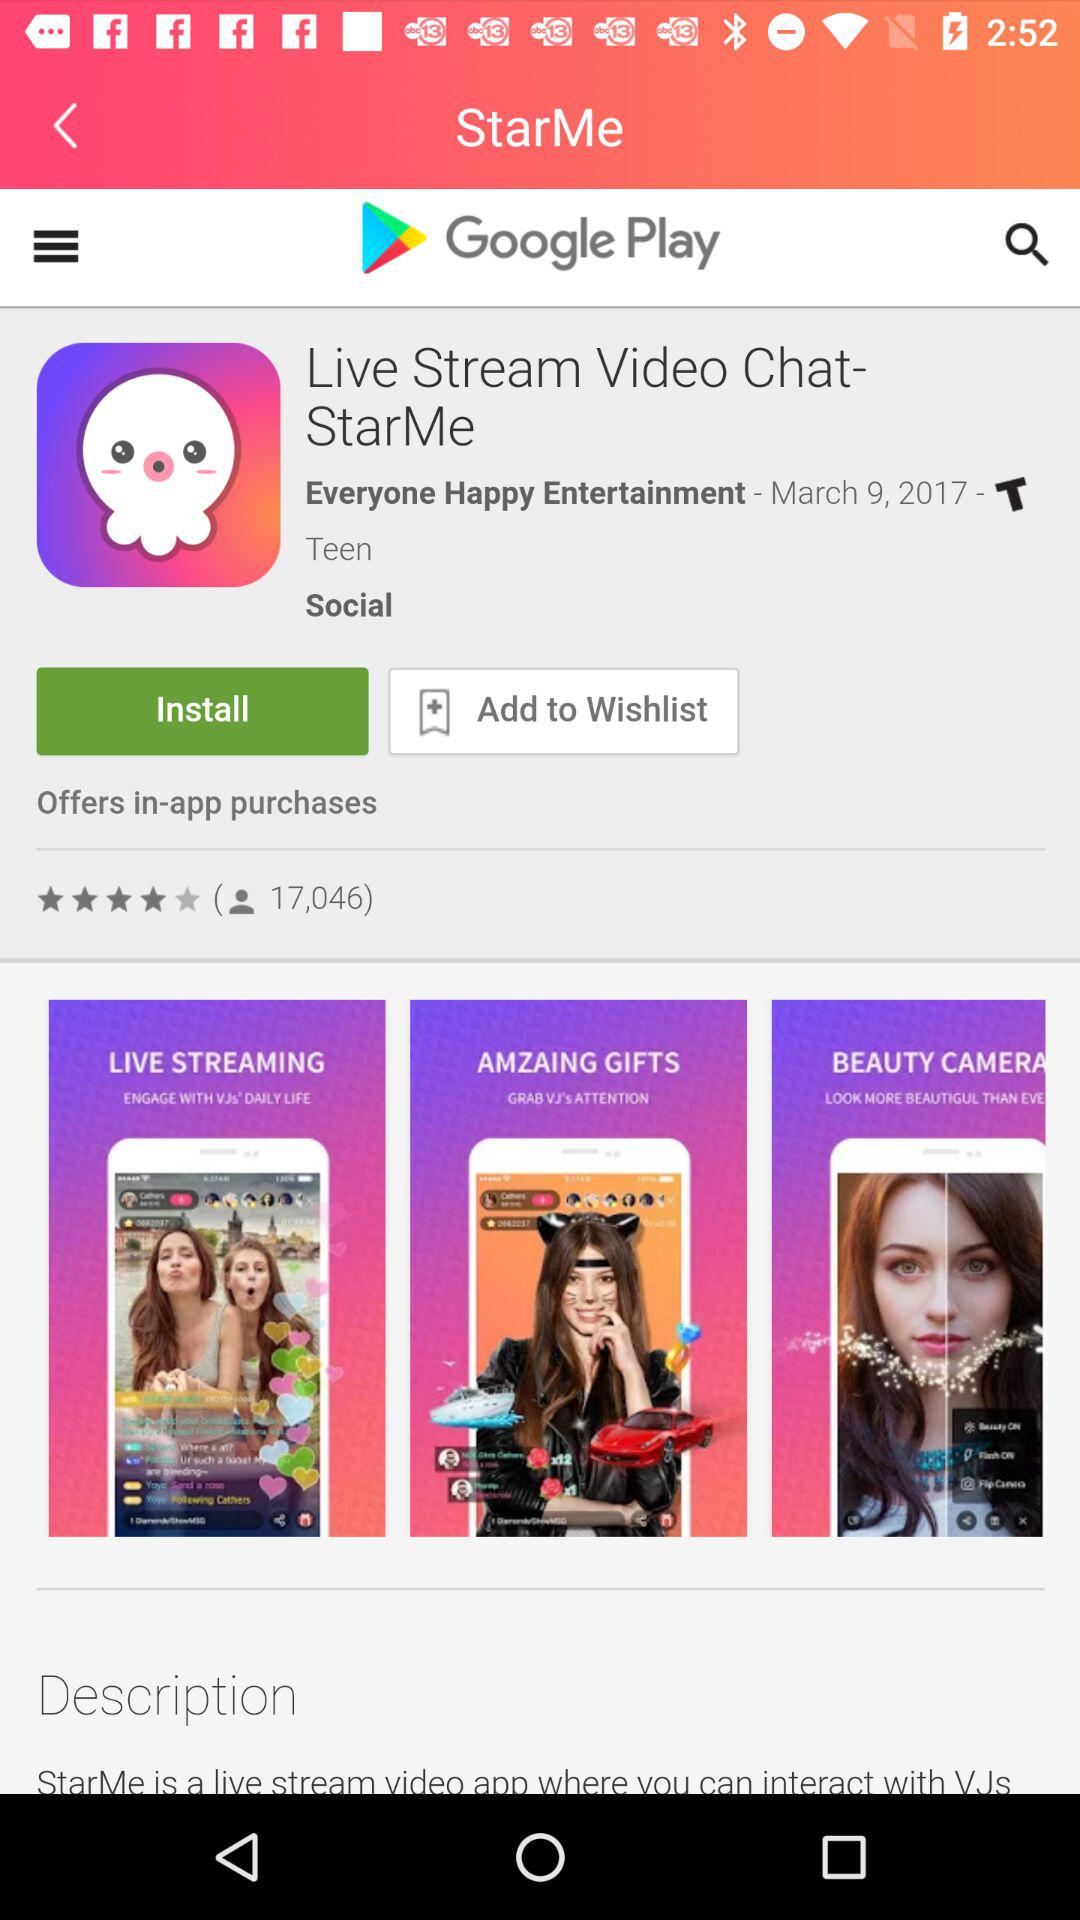What are the star ratings of the application? The rating is 4 stars. 